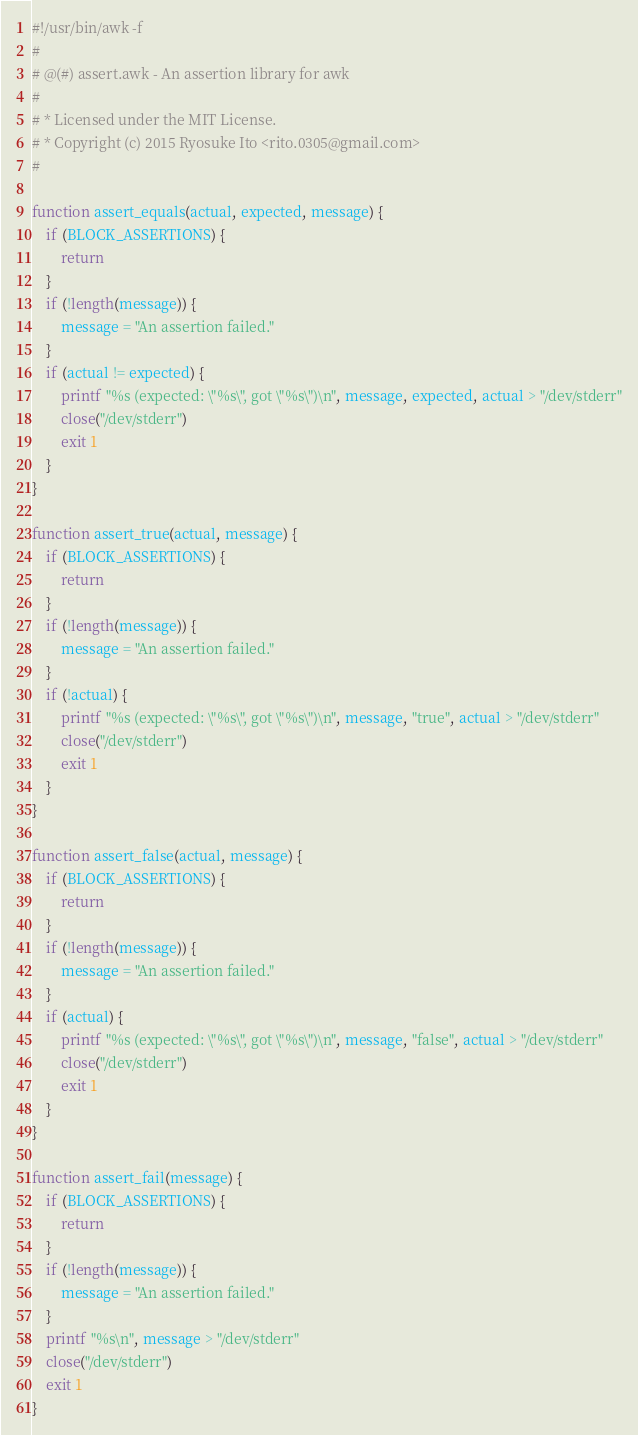Convert code to text. <code><loc_0><loc_0><loc_500><loc_500><_Awk_>#!/usr/bin/awk -f
#
# @(#) assert.awk - An assertion library for awk
#
# * Licensed under the MIT License.
# * Copyright (c) 2015 Ryosuke Ito <rito.0305@gmail.com>
#

function assert_equals(actual, expected, message) {
    if (BLOCK_ASSERTIONS) {
        return
    }
    if (!length(message)) {
        message = "An assertion failed."
    }
    if (actual != expected) {
        printf "%s (expected: \"%s\", got \"%s\")\n", message, expected, actual > "/dev/stderr"
        close("/dev/stderr")
        exit 1
    }
}

function assert_true(actual, message) {
    if (BLOCK_ASSERTIONS) {
        return
    }
    if (!length(message)) {
        message = "An assertion failed."
    }
    if (!actual) {
        printf "%s (expected: \"%s\", got \"%s\")\n", message, "true", actual > "/dev/stderr"
        close("/dev/stderr")
        exit 1
    }
}

function assert_false(actual, message) {
    if (BLOCK_ASSERTIONS) {
        return
    }
    if (!length(message)) {
        message = "An assertion failed."
    }
    if (actual) {
        printf "%s (expected: \"%s\", got \"%s\")\n", message, "false", actual > "/dev/stderr"
        close("/dev/stderr")
        exit 1
    }
}

function assert_fail(message) {
    if (BLOCK_ASSERTIONS) {
        return
    }
    if (!length(message)) {
        message = "An assertion failed."
    }
    printf "%s\n", message > "/dev/stderr"
    close("/dev/stderr")
    exit 1
}

</code> 